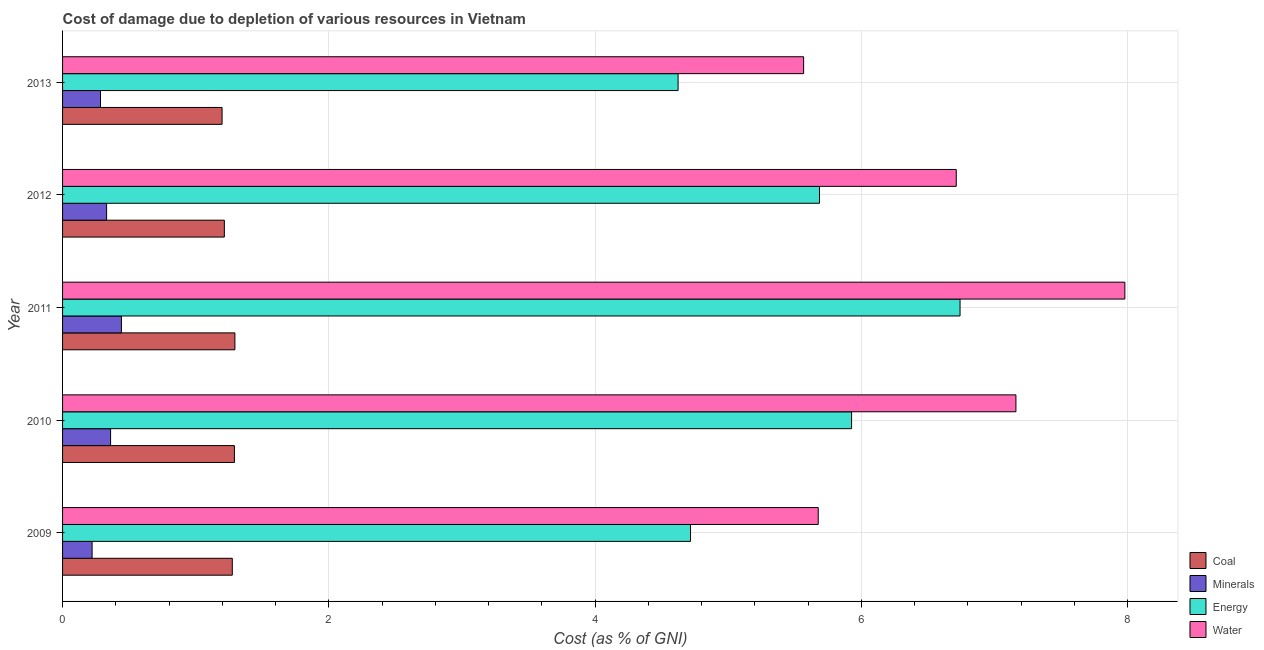How many groups of bars are there?
Make the answer very short. 5. Are the number of bars on each tick of the Y-axis equal?
Offer a terse response. Yes. In how many cases, is the number of bars for a given year not equal to the number of legend labels?
Provide a succinct answer. 0. What is the cost of damage due to depletion of minerals in 2011?
Your answer should be very brief. 0.44. Across all years, what is the maximum cost of damage due to depletion of water?
Ensure brevity in your answer.  7.98. Across all years, what is the minimum cost of damage due to depletion of minerals?
Offer a very short reply. 0.22. What is the total cost of damage due to depletion of water in the graph?
Provide a short and direct response. 33.09. What is the difference between the cost of damage due to depletion of water in 2010 and that in 2013?
Offer a terse response. 1.59. What is the difference between the cost of damage due to depletion of minerals in 2012 and the cost of damage due to depletion of water in 2013?
Your answer should be very brief. -5.24. What is the average cost of damage due to depletion of coal per year?
Your answer should be very brief. 1.25. In the year 2012, what is the difference between the cost of damage due to depletion of water and cost of damage due to depletion of minerals?
Give a very brief answer. 6.38. In how many years, is the cost of damage due to depletion of coal greater than 6 %?
Provide a succinct answer. 0. What is the ratio of the cost of damage due to depletion of minerals in 2011 to that in 2013?
Provide a succinct answer. 1.55. Is the cost of damage due to depletion of coal in 2009 less than that in 2010?
Offer a terse response. Yes. Is the difference between the cost of damage due to depletion of coal in 2010 and 2013 greater than the difference between the cost of damage due to depletion of water in 2010 and 2013?
Provide a short and direct response. No. What is the difference between the highest and the second highest cost of damage due to depletion of coal?
Offer a terse response. 0. What is the difference between the highest and the lowest cost of damage due to depletion of minerals?
Give a very brief answer. 0.22. Is the sum of the cost of damage due to depletion of minerals in 2012 and 2013 greater than the maximum cost of damage due to depletion of water across all years?
Keep it short and to the point. No. What does the 2nd bar from the top in 2011 represents?
Give a very brief answer. Energy. What does the 3rd bar from the bottom in 2011 represents?
Your answer should be compact. Energy. Is it the case that in every year, the sum of the cost of damage due to depletion of coal and cost of damage due to depletion of minerals is greater than the cost of damage due to depletion of energy?
Ensure brevity in your answer.  No. How many bars are there?
Provide a succinct answer. 20. Are all the bars in the graph horizontal?
Provide a succinct answer. Yes. What is the difference between two consecutive major ticks on the X-axis?
Your answer should be compact. 2. How many legend labels are there?
Ensure brevity in your answer.  4. What is the title of the graph?
Provide a short and direct response. Cost of damage due to depletion of various resources in Vietnam . What is the label or title of the X-axis?
Your response must be concise. Cost (as % of GNI). What is the Cost (as % of GNI) of Coal in 2009?
Keep it short and to the point. 1.27. What is the Cost (as % of GNI) of Minerals in 2009?
Provide a succinct answer. 0.22. What is the Cost (as % of GNI) of Energy in 2009?
Provide a short and direct response. 4.72. What is the Cost (as % of GNI) in Water in 2009?
Offer a very short reply. 5.68. What is the Cost (as % of GNI) of Coal in 2010?
Ensure brevity in your answer.  1.29. What is the Cost (as % of GNI) of Minerals in 2010?
Your answer should be very brief. 0.36. What is the Cost (as % of GNI) in Energy in 2010?
Your response must be concise. 5.93. What is the Cost (as % of GNI) of Water in 2010?
Give a very brief answer. 7.16. What is the Cost (as % of GNI) of Coal in 2011?
Keep it short and to the point. 1.29. What is the Cost (as % of GNI) of Minerals in 2011?
Give a very brief answer. 0.44. What is the Cost (as % of GNI) of Energy in 2011?
Provide a short and direct response. 6.74. What is the Cost (as % of GNI) of Water in 2011?
Offer a very short reply. 7.98. What is the Cost (as % of GNI) of Coal in 2012?
Your response must be concise. 1.22. What is the Cost (as % of GNI) of Minerals in 2012?
Ensure brevity in your answer.  0.33. What is the Cost (as % of GNI) in Energy in 2012?
Offer a terse response. 5.69. What is the Cost (as % of GNI) of Water in 2012?
Keep it short and to the point. 6.71. What is the Cost (as % of GNI) in Coal in 2013?
Your answer should be compact. 1.2. What is the Cost (as % of GNI) in Minerals in 2013?
Offer a very short reply. 0.28. What is the Cost (as % of GNI) of Energy in 2013?
Give a very brief answer. 4.62. What is the Cost (as % of GNI) of Water in 2013?
Your answer should be very brief. 5.57. Across all years, what is the maximum Cost (as % of GNI) in Coal?
Ensure brevity in your answer.  1.29. Across all years, what is the maximum Cost (as % of GNI) of Minerals?
Offer a very short reply. 0.44. Across all years, what is the maximum Cost (as % of GNI) of Energy?
Make the answer very short. 6.74. Across all years, what is the maximum Cost (as % of GNI) in Water?
Ensure brevity in your answer.  7.98. Across all years, what is the minimum Cost (as % of GNI) in Coal?
Provide a short and direct response. 1.2. Across all years, what is the minimum Cost (as % of GNI) in Minerals?
Offer a terse response. 0.22. Across all years, what is the minimum Cost (as % of GNI) in Energy?
Offer a terse response. 4.62. Across all years, what is the minimum Cost (as % of GNI) in Water?
Your answer should be very brief. 5.57. What is the total Cost (as % of GNI) in Coal in the graph?
Your answer should be compact. 6.27. What is the total Cost (as % of GNI) in Minerals in the graph?
Your response must be concise. 1.64. What is the total Cost (as % of GNI) of Energy in the graph?
Make the answer very short. 27.69. What is the total Cost (as % of GNI) in Water in the graph?
Your answer should be compact. 33.09. What is the difference between the Cost (as % of GNI) of Coal in 2009 and that in 2010?
Keep it short and to the point. -0.02. What is the difference between the Cost (as % of GNI) in Minerals in 2009 and that in 2010?
Provide a succinct answer. -0.14. What is the difference between the Cost (as % of GNI) in Energy in 2009 and that in 2010?
Provide a short and direct response. -1.21. What is the difference between the Cost (as % of GNI) of Water in 2009 and that in 2010?
Provide a succinct answer. -1.48. What is the difference between the Cost (as % of GNI) of Coal in 2009 and that in 2011?
Make the answer very short. -0.02. What is the difference between the Cost (as % of GNI) of Minerals in 2009 and that in 2011?
Offer a very short reply. -0.22. What is the difference between the Cost (as % of GNI) in Energy in 2009 and that in 2011?
Your answer should be very brief. -2.02. What is the difference between the Cost (as % of GNI) in Water in 2009 and that in 2011?
Provide a succinct answer. -2.3. What is the difference between the Cost (as % of GNI) of Coal in 2009 and that in 2012?
Keep it short and to the point. 0.06. What is the difference between the Cost (as % of GNI) in Minerals in 2009 and that in 2012?
Your answer should be compact. -0.11. What is the difference between the Cost (as % of GNI) of Energy in 2009 and that in 2012?
Make the answer very short. -0.97. What is the difference between the Cost (as % of GNI) in Water in 2009 and that in 2012?
Ensure brevity in your answer.  -1.04. What is the difference between the Cost (as % of GNI) in Coal in 2009 and that in 2013?
Your response must be concise. 0.08. What is the difference between the Cost (as % of GNI) of Minerals in 2009 and that in 2013?
Provide a succinct answer. -0.06. What is the difference between the Cost (as % of GNI) in Energy in 2009 and that in 2013?
Offer a terse response. 0.09. What is the difference between the Cost (as % of GNI) in Water in 2009 and that in 2013?
Keep it short and to the point. 0.11. What is the difference between the Cost (as % of GNI) in Coal in 2010 and that in 2011?
Your response must be concise. -0. What is the difference between the Cost (as % of GNI) of Minerals in 2010 and that in 2011?
Offer a terse response. -0.08. What is the difference between the Cost (as % of GNI) in Energy in 2010 and that in 2011?
Offer a very short reply. -0.81. What is the difference between the Cost (as % of GNI) in Water in 2010 and that in 2011?
Offer a very short reply. -0.82. What is the difference between the Cost (as % of GNI) in Coal in 2010 and that in 2012?
Your answer should be very brief. 0.08. What is the difference between the Cost (as % of GNI) in Minerals in 2010 and that in 2012?
Your response must be concise. 0.03. What is the difference between the Cost (as % of GNI) in Energy in 2010 and that in 2012?
Give a very brief answer. 0.24. What is the difference between the Cost (as % of GNI) in Water in 2010 and that in 2012?
Keep it short and to the point. 0.45. What is the difference between the Cost (as % of GNI) of Coal in 2010 and that in 2013?
Make the answer very short. 0.09. What is the difference between the Cost (as % of GNI) in Minerals in 2010 and that in 2013?
Offer a very short reply. 0.08. What is the difference between the Cost (as % of GNI) of Energy in 2010 and that in 2013?
Offer a very short reply. 1.3. What is the difference between the Cost (as % of GNI) in Water in 2010 and that in 2013?
Your answer should be compact. 1.59. What is the difference between the Cost (as % of GNI) of Coal in 2011 and that in 2012?
Offer a terse response. 0.08. What is the difference between the Cost (as % of GNI) of Minerals in 2011 and that in 2012?
Offer a terse response. 0.11. What is the difference between the Cost (as % of GNI) in Energy in 2011 and that in 2012?
Ensure brevity in your answer.  1.06. What is the difference between the Cost (as % of GNI) of Water in 2011 and that in 2012?
Your answer should be compact. 1.27. What is the difference between the Cost (as % of GNI) in Coal in 2011 and that in 2013?
Provide a short and direct response. 0.1. What is the difference between the Cost (as % of GNI) of Minerals in 2011 and that in 2013?
Give a very brief answer. 0.16. What is the difference between the Cost (as % of GNI) of Energy in 2011 and that in 2013?
Your response must be concise. 2.12. What is the difference between the Cost (as % of GNI) in Water in 2011 and that in 2013?
Provide a short and direct response. 2.41. What is the difference between the Cost (as % of GNI) of Coal in 2012 and that in 2013?
Provide a short and direct response. 0.02. What is the difference between the Cost (as % of GNI) in Minerals in 2012 and that in 2013?
Offer a terse response. 0.05. What is the difference between the Cost (as % of GNI) in Energy in 2012 and that in 2013?
Keep it short and to the point. 1.06. What is the difference between the Cost (as % of GNI) in Water in 2012 and that in 2013?
Offer a terse response. 1.15. What is the difference between the Cost (as % of GNI) of Coal in 2009 and the Cost (as % of GNI) of Minerals in 2010?
Ensure brevity in your answer.  0.91. What is the difference between the Cost (as % of GNI) in Coal in 2009 and the Cost (as % of GNI) in Energy in 2010?
Give a very brief answer. -4.65. What is the difference between the Cost (as % of GNI) of Coal in 2009 and the Cost (as % of GNI) of Water in 2010?
Provide a short and direct response. -5.89. What is the difference between the Cost (as % of GNI) in Minerals in 2009 and the Cost (as % of GNI) in Energy in 2010?
Give a very brief answer. -5.7. What is the difference between the Cost (as % of GNI) in Minerals in 2009 and the Cost (as % of GNI) in Water in 2010?
Your response must be concise. -6.94. What is the difference between the Cost (as % of GNI) of Energy in 2009 and the Cost (as % of GNI) of Water in 2010?
Keep it short and to the point. -2.44. What is the difference between the Cost (as % of GNI) in Coal in 2009 and the Cost (as % of GNI) in Minerals in 2011?
Make the answer very short. 0.83. What is the difference between the Cost (as % of GNI) in Coal in 2009 and the Cost (as % of GNI) in Energy in 2011?
Ensure brevity in your answer.  -5.47. What is the difference between the Cost (as % of GNI) in Coal in 2009 and the Cost (as % of GNI) in Water in 2011?
Ensure brevity in your answer.  -6.7. What is the difference between the Cost (as % of GNI) of Minerals in 2009 and the Cost (as % of GNI) of Energy in 2011?
Give a very brief answer. -6.52. What is the difference between the Cost (as % of GNI) of Minerals in 2009 and the Cost (as % of GNI) of Water in 2011?
Offer a very short reply. -7.76. What is the difference between the Cost (as % of GNI) in Energy in 2009 and the Cost (as % of GNI) in Water in 2011?
Provide a succinct answer. -3.26. What is the difference between the Cost (as % of GNI) of Coal in 2009 and the Cost (as % of GNI) of Minerals in 2012?
Provide a succinct answer. 0.94. What is the difference between the Cost (as % of GNI) in Coal in 2009 and the Cost (as % of GNI) in Energy in 2012?
Give a very brief answer. -4.41. What is the difference between the Cost (as % of GNI) in Coal in 2009 and the Cost (as % of GNI) in Water in 2012?
Make the answer very short. -5.44. What is the difference between the Cost (as % of GNI) of Minerals in 2009 and the Cost (as % of GNI) of Energy in 2012?
Your answer should be very brief. -5.46. What is the difference between the Cost (as % of GNI) in Minerals in 2009 and the Cost (as % of GNI) in Water in 2012?
Provide a succinct answer. -6.49. What is the difference between the Cost (as % of GNI) in Energy in 2009 and the Cost (as % of GNI) in Water in 2012?
Provide a short and direct response. -2. What is the difference between the Cost (as % of GNI) of Coal in 2009 and the Cost (as % of GNI) of Minerals in 2013?
Keep it short and to the point. 0.99. What is the difference between the Cost (as % of GNI) of Coal in 2009 and the Cost (as % of GNI) of Energy in 2013?
Offer a very short reply. -3.35. What is the difference between the Cost (as % of GNI) of Coal in 2009 and the Cost (as % of GNI) of Water in 2013?
Your answer should be very brief. -4.29. What is the difference between the Cost (as % of GNI) of Minerals in 2009 and the Cost (as % of GNI) of Energy in 2013?
Make the answer very short. -4.4. What is the difference between the Cost (as % of GNI) of Minerals in 2009 and the Cost (as % of GNI) of Water in 2013?
Your answer should be compact. -5.34. What is the difference between the Cost (as % of GNI) of Energy in 2009 and the Cost (as % of GNI) of Water in 2013?
Offer a terse response. -0.85. What is the difference between the Cost (as % of GNI) of Coal in 2010 and the Cost (as % of GNI) of Minerals in 2011?
Provide a short and direct response. 0.85. What is the difference between the Cost (as % of GNI) of Coal in 2010 and the Cost (as % of GNI) of Energy in 2011?
Ensure brevity in your answer.  -5.45. What is the difference between the Cost (as % of GNI) in Coal in 2010 and the Cost (as % of GNI) in Water in 2011?
Provide a short and direct response. -6.69. What is the difference between the Cost (as % of GNI) in Minerals in 2010 and the Cost (as % of GNI) in Energy in 2011?
Provide a short and direct response. -6.38. What is the difference between the Cost (as % of GNI) of Minerals in 2010 and the Cost (as % of GNI) of Water in 2011?
Offer a terse response. -7.62. What is the difference between the Cost (as % of GNI) of Energy in 2010 and the Cost (as % of GNI) of Water in 2011?
Offer a very short reply. -2.05. What is the difference between the Cost (as % of GNI) of Coal in 2010 and the Cost (as % of GNI) of Minerals in 2012?
Your answer should be compact. 0.96. What is the difference between the Cost (as % of GNI) in Coal in 2010 and the Cost (as % of GNI) in Energy in 2012?
Your response must be concise. -4.39. What is the difference between the Cost (as % of GNI) of Coal in 2010 and the Cost (as % of GNI) of Water in 2012?
Keep it short and to the point. -5.42. What is the difference between the Cost (as % of GNI) in Minerals in 2010 and the Cost (as % of GNI) in Energy in 2012?
Your answer should be compact. -5.32. What is the difference between the Cost (as % of GNI) in Minerals in 2010 and the Cost (as % of GNI) in Water in 2012?
Provide a short and direct response. -6.35. What is the difference between the Cost (as % of GNI) of Energy in 2010 and the Cost (as % of GNI) of Water in 2012?
Ensure brevity in your answer.  -0.79. What is the difference between the Cost (as % of GNI) in Coal in 2010 and the Cost (as % of GNI) in Minerals in 2013?
Give a very brief answer. 1.01. What is the difference between the Cost (as % of GNI) in Coal in 2010 and the Cost (as % of GNI) in Energy in 2013?
Keep it short and to the point. -3.33. What is the difference between the Cost (as % of GNI) of Coal in 2010 and the Cost (as % of GNI) of Water in 2013?
Provide a short and direct response. -4.28. What is the difference between the Cost (as % of GNI) of Minerals in 2010 and the Cost (as % of GNI) of Energy in 2013?
Give a very brief answer. -4.26. What is the difference between the Cost (as % of GNI) in Minerals in 2010 and the Cost (as % of GNI) in Water in 2013?
Make the answer very short. -5.21. What is the difference between the Cost (as % of GNI) in Energy in 2010 and the Cost (as % of GNI) in Water in 2013?
Give a very brief answer. 0.36. What is the difference between the Cost (as % of GNI) in Coal in 2011 and the Cost (as % of GNI) in Minerals in 2012?
Your answer should be very brief. 0.96. What is the difference between the Cost (as % of GNI) of Coal in 2011 and the Cost (as % of GNI) of Energy in 2012?
Give a very brief answer. -4.39. What is the difference between the Cost (as % of GNI) in Coal in 2011 and the Cost (as % of GNI) in Water in 2012?
Your answer should be compact. -5.42. What is the difference between the Cost (as % of GNI) of Minerals in 2011 and the Cost (as % of GNI) of Energy in 2012?
Give a very brief answer. -5.24. What is the difference between the Cost (as % of GNI) in Minerals in 2011 and the Cost (as % of GNI) in Water in 2012?
Provide a succinct answer. -6.27. What is the difference between the Cost (as % of GNI) in Energy in 2011 and the Cost (as % of GNI) in Water in 2012?
Keep it short and to the point. 0.03. What is the difference between the Cost (as % of GNI) of Coal in 2011 and the Cost (as % of GNI) of Minerals in 2013?
Your answer should be compact. 1.01. What is the difference between the Cost (as % of GNI) of Coal in 2011 and the Cost (as % of GNI) of Energy in 2013?
Your answer should be compact. -3.33. What is the difference between the Cost (as % of GNI) of Coal in 2011 and the Cost (as % of GNI) of Water in 2013?
Make the answer very short. -4.27. What is the difference between the Cost (as % of GNI) in Minerals in 2011 and the Cost (as % of GNI) in Energy in 2013?
Provide a succinct answer. -4.18. What is the difference between the Cost (as % of GNI) in Minerals in 2011 and the Cost (as % of GNI) in Water in 2013?
Keep it short and to the point. -5.12. What is the difference between the Cost (as % of GNI) of Energy in 2011 and the Cost (as % of GNI) of Water in 2013?
Give a very brief answer. 1.17. What is the difference between the Cost (as % of GNI) of Coal in 2012 and the Cost (as % of GNI) of Minerals in 2013?
Your response must be concise. 0.93. What is the difference between the Cost (as % of GNI) of Coal in 2012 and the Cost (as % of GNI) of Energy in 2013?
Your answer should be very brief. -3.41. What is the difference between the Cost (as % of GNI) of Coal in 2012 and the Cost (as % of GNI) of Water in 2013?
Give a very brief answer. -4.35. What is the difference between the Cost (as % of GNI) in Minerals in 2012 and the Cost (as % of GNI) in Energy in 2013?
Provide a short and direct response. -4.29. What is the difference between the Cost (as % of GNI) of Minerals in 2012 and the Cost (as % of GNI) of Water in 2013?
Provide a succinct answer. -5.24. What is the difference between the Cost (as % of GNI) of Energy in 2012 and the Cost (as % of GNI) of Water in 2013?
Give a very brief answer. 0.12. What is the average Cost (as % of GNI) in Coal per year?
Make the answer very short. 1.25. What is the average Cost (as % of GNI) of Minerals per year?
Your answer should be very brief. 0.33. What is the average Cost (as % of GNI) in Energy per year?
Keep it short and to the point. 5.54. What is the average Cost (as % of GNI) of Water per year?
Make the answer very short. 6.62. In the year 2009, what is the difference between the Cost (as % of GNI) of Coal and Cost (as % of GNI) of Minerals?
Your response must be concise. 1.05. In the year 2009, what is the difference between the Cost (as % of GNI) of Coal and Cost (as % of GNI) of Energy?
Your answer should be very brief. -3.44. In the year 2009, what is the difference between the Cost (as % of GNI) of Coal and Cost (as % of GNI) of Water?
Offer a terse response. -4.4. In the year 2009, what is the difference between the Cost (as % of GNI) in Minerals and Cost (as % of GNI) in Energy?
Your answer should be very brief. -4.49. In the year 2009, what is the difference between the Cost (as % of GNI) in Minerals and Cost (as % of GNI) in Water?
Offer a very short reply. -5.45. In the year 2009, what is the difference between the Cost (as % of GNI) in Energy and Cost (as % of GNI) in Water?
Provide a succinct answer. -0.96. In the year 2010, what is the difference between the Cost (as % of GNI) of Coal and Cost (as % of GNI) of Minerals?
Offer a very short reply. 0.93. In the year 2010, what is the difference between the Cost (as % of GNI) of Coal and Cost (as % of GNI) of Energy?
Your answer should be very brief. -4.64. In the year 2010, what is the difference between the Cost (as % of GNI) in Coal and Cost (as % of GNI) in Water?
Your answer should be compact. -5.87. In the year 2010, what is the difference between the Cost (as % of GNI) of Minerals and Cost (as % of GNI) of Energy?
Provide a succinct answer. -5.57. In the year 2010, what is the difference between the Cost (as % of GNI) of Minerals and Cost (as % of GNI) of Water?
Provide a short and direct response. -6.8. In the year 2010, what is the difference between the Cost (as % of GNI) in Energy and Cost (as % of GNI) in Water?
Give a very brief answer. -1.23. In the year 2011, what is the difference between the Cost (as % of GNI) of Coal and Cost (as % of GNI) of Minerals?
Make the answer very short. 0.85. In the year 2011, what is the difference between the Cost (as % of GNI) in Coal and Cost (as % of GNI) in Energy?
Offer a very short reply. -5.45. In the year 2011, what is the difference between the Cost (as % of GNI) of Coal and Cost (as % of GNI) of Water?
Provide a short and direct response. -6.68. In the year 2011, what is the difference between the Cost (as % of GNI) in Minerals and Cost (as % of GNI) in Energy?
Provide a succinct answer. -6.3. In the year 2011, what is the difference between the Cost (as % of GNI) in Minerals and Cost (as % of GNI) in Water?
Your answer should be compact. -7.54. In the year 2011, what is the difference between the Cost (as % of GNI) of Energy and Cost (as % of GNI) of Water?
Provide a short and direct response. -1.24. In the year 2012, what is the difference between the Cost (as % of GNI) of Coal and Cost (as % of GNI) of Minerals?
Give a very brief answer. 0.88. In the year 2012, what is the difference between the Cost (as % of GNI) in Coal and Cost (as % of GNI) in Energy?
Your answer should be compact. -4.47. In the year 2012, what is the difference between the Cost (as % of GNI) in Coal and Cost (as % of GNI) in Water?
Offer a terse response. -5.5. In the year 2012, what is the difference between the Cost (as % of GNI) of Minerals and Cost (as % of GNI) of Energy?
Your response must be concise. -5.35. In the year 2012, what is the difference between the Cost (as % of GNI) of Minerals and Cost (as % of GNI) of Water?
Provide a succinct answer. -6.38. In the year 2012, what is the difference between the Cost (as % of GNI) in Energy and Cost (as % of GNI) in Water?
Provide a succinct answer. -1.03. In the year 2013, what is the difference between the Cost (as % of GNI) of Coal and Cost (as % of GNI) of Minerals?
Make the answer very short. 0.91. In the year 2013, what is the difference between the Cost (as % of GNI) in Coal and Cost (as % of GNI) in Energy?
Provide a succinct answer. -3.43. In the year 2013, what is the difference between the Cost (as % of GNI) in Coal and Cost (as % of GNI) in Water?
Provide a short and direct response. -4.37. In the year 2013, what is the difference between the Cost (as % of GNI) in Minerals and Cost (as % of GNI) in Energy?
Your response must be concise. -4.34. In the year 2013, what is the difference between the Cost (as % of GNI) of Minerals and Cost (as % of GNI) of Water?
Offer a very short reply. -5.28. In the year 2013, what is the difference between the Cost (as % of GNI) in Energy and Cost (as % of GNI) in Water?
Ensure brevity in your answer.  -0.94. What is the ratio of the Cost (as % of GNI) in Minerals in 2009 to that in 2010?
Your answer should be very brief. 0.61. What is the ratio of the Cost (as % of GNI) of Energy in 2009 to that in 2010?
Offer a very short reply. 0.8. What is the ratio of the Cost (as % of GNI) in Water in 2009 to that in 2010?
Your answer should be very brief. 0.79. What is the ratio of the Cost (as % of GNI) in Coal in 2009 to that in 2011?
Give a very brief answer. 0.98. What is the ratio of the Cost (as % of GNI) of Minerals in 2009 to that in 2011?
Make the answer very short. 0.5. What is the ratio of the Cost (as % of GNI) in Energy in 2009 to that in 2011?
Offer a terse response. 0.7. What is the ratio of the Cost (as % of GNI) of Water in 2009 to that in 2011?
Provide a succinct answer. 0.71. What is the ratio of the Cost (as % of GNI) of Coal in 2009 to that in 2012?
Your response must be concise. 1.05. What is the ratio of the Cost (as % of GNI) of Minerals in 2009 to that in 2012?
Provide a short and direct response. 0.67. What is the ratio of the Cost (as % of GNI) of Energy in 2009 to that in 2012?
Make the answer very short. 0.83. What is the ratio of the Cost (as % of GNI) of Water in 2009 to that in 2012?
Make the answer very short. 0.85. What is the ratio of the Cost (as % of GNI) of Coal in 2009 to that in 2013?
Your answer should be compact. 1.06. What is the ratio of the Cost (as % of GNI) in Minerals in 2009 to that in 2013?
Provide a succinct answer. 0.78. What is the ratio of the Cost (as % of GNI) of Energy in 2009 to that in 2013?
Provide a succinct answer. 1.02. What is the ratio of the Cost (as % of GNI) in Water in 2009 to that in 2013?
Your answer should be compact. 1.02. What is the ratio of the Cost (as % of GNI) in Coal in 2010 to that in 2011?
Your answer should be very brief. 1. What is the ratio of the Cost (as % of GNI) of Minerals in 2010 to that in 2011?
Offer a very short reply. 0.82. What is the ratio of the Cost (as % of GNI) in Energy in 2010 to that in 2011?
Ensure brevity in your answer.  0.88. What is the ratio of the Cost (as % of GNI) of Water in 2010 to that in 2011?
Ensure brevity in your answer.  0.9. What is the ratio of the Cost (as % of GNI) of Coal in 2010 to that in 2012?
Your response must be concise. 1.06. What is the ratio of the Cost (as % of GNI) of Minerals in 2010 to that in 2012?
Provide a succinct answer. 1.09. What is the ratio of the Cost (as % of GNI) of Energy in 2010 to that in 2012?
Ensure brevity in your answer.  1.04. What is the ratio of the Cost (as % of GNI) in Water in 2010 to that in 2012?
Make the answer very short. 1.07. What is the ratio of the Cost (as % of GNI) in Coal in 2010 to that in 2013?
Offer a terse response. 1.08. What is the ratio of the Cost (as % of GNI) of Minerals in 2010 to that in 2013?
Provide a succinct answer. 1.27. What is the ratio of the Cost (as % of GNI) in Energy in 2010 to that in 2013?
Your response must be concise. 1.28. What is the ratio of the Cost (as % of GNI) in Water in 2010 to that in 2013?
Keep it short and to the point. 1.29. What is the ratio of the Cost (as % of GNI) in Coal in 2011 to that in 2012?
Keep it short and to the point. 1.07. What is the ratio of the Cost (as % of GNI) in Minerals in 2011 to that in 2012?
Keep it short and to the point. 1.34. What is the ratio of the Cost (as % of GNI) in Energy in 2011 to that in 2012?
Your response must be concise. 1.19. What is the ratio of the Cost (as % of GNI) in Water in 2011 to that in 2012?
Offer a very short reply. 1.19. What is the ratio of the Cost (as % of GNI) in Coal in 2011 to that in 2013?
Offer a terse response. 1.08. What is the ratio of the Cost (as % of GNI) in Minerals in 2011 to that in 2013?
Offer a terse response. 1.55. What is the ratio of the Cost (as % of GNI) of Energy in 2011 to that in 2013?
Your response must be concise. 1.46. What is the ratio of the Cost (as % of GNI) of Water in 2011 to that in 2013?
Provide a short and direct response. 1.43. What is the ratio of the Cost (as % of GNI) in Coal in 2012 to that in 2013?
Keep it short and to the point. 1.01. What is the ratio of the Cost (as % of GNI) in Minerals in 2012 to that in 2013?
Your response must be concise. 1.16. What is the ratio of the Cost (as % of GNI) of Energy in 2012 to that in 2013?
Provide a succinct answer. 1.23. What is the ratio of the Cost (as % of GNI) in Water in 2012 to that in 2013?
Give a very brief answer. 1.21. What is the difference between the highest and the second highest Cost (as % of GNI) of Coal?
Give a very brief answer. 0. What is the difference between the highest and the second highest Cost (as % of GNI) in Minerals?
Provide a succinct answer. 0.08. What is the difference between the highest and the second highest Cost (as % of GNI) in Energy?
Provide a succinct answer. 0.81. What is the difference between the highest and the second highest Cost (as % of GNI) in Water?
Your answer should be very brief. 0.82. What is the difference between the highest and the lowest Cost (as % of GNI) in Coal?
Ensure brevity in your answer.  0.1. What is the difference between the highest and the lowest Cost (as % of GNI) of Minerals?
Keep it short and to the point. 0.22. What is the difference between the highest and the lowest Cost (as % of GNI) of Energy?
Your answer should be very brief. 2.12. What is the difference between the highest and the lowest Cost (as % of GNI) in Water?
Your answer should be compact. 2.41. 